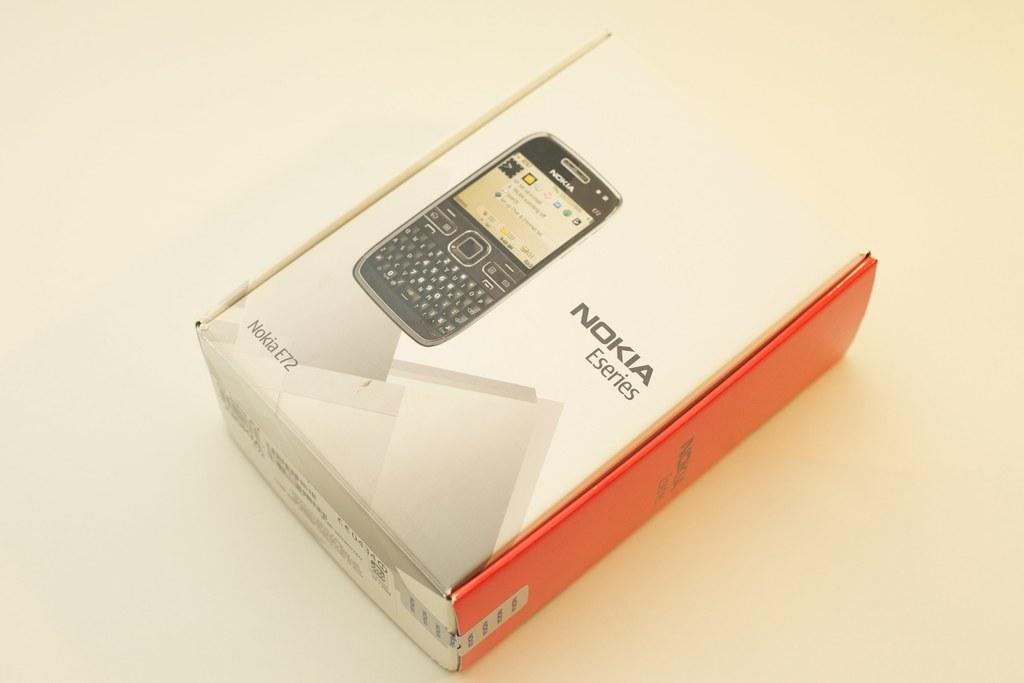<image>
Offer a succinct explanation of the picture presented. a  Nokia phone with an orange side on it 